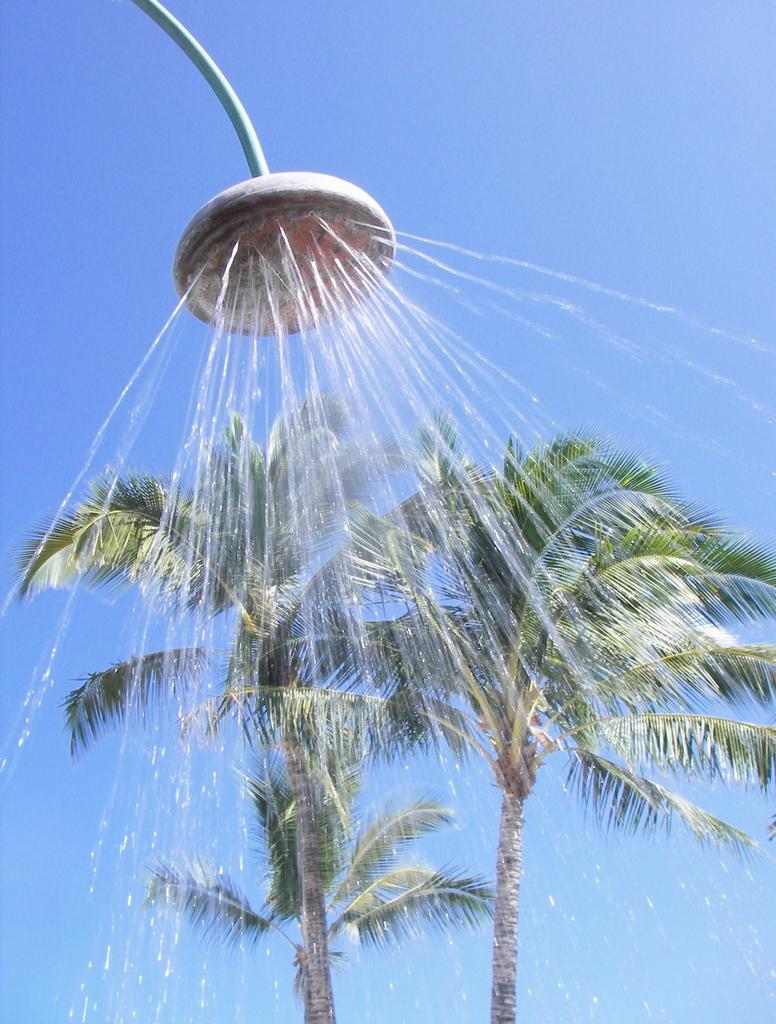How many trees can be seen in the image? There are two trees in the image. Where are the trees located in relation to the image? The trees are located at the bottom of the image. What other object can be seen in the image? There is a shower in the image. Where is the shower located in the image? The shower is located at the top of the image. What color is the sky in the background of the image? The sky is blue in the background of the image. What type of stamp can be seen on the shower in the image? There is no stamp present on the shower in the image. How does the ice affect the trees in the image? There is no ice present in the image, so it cannot affect the trees. 